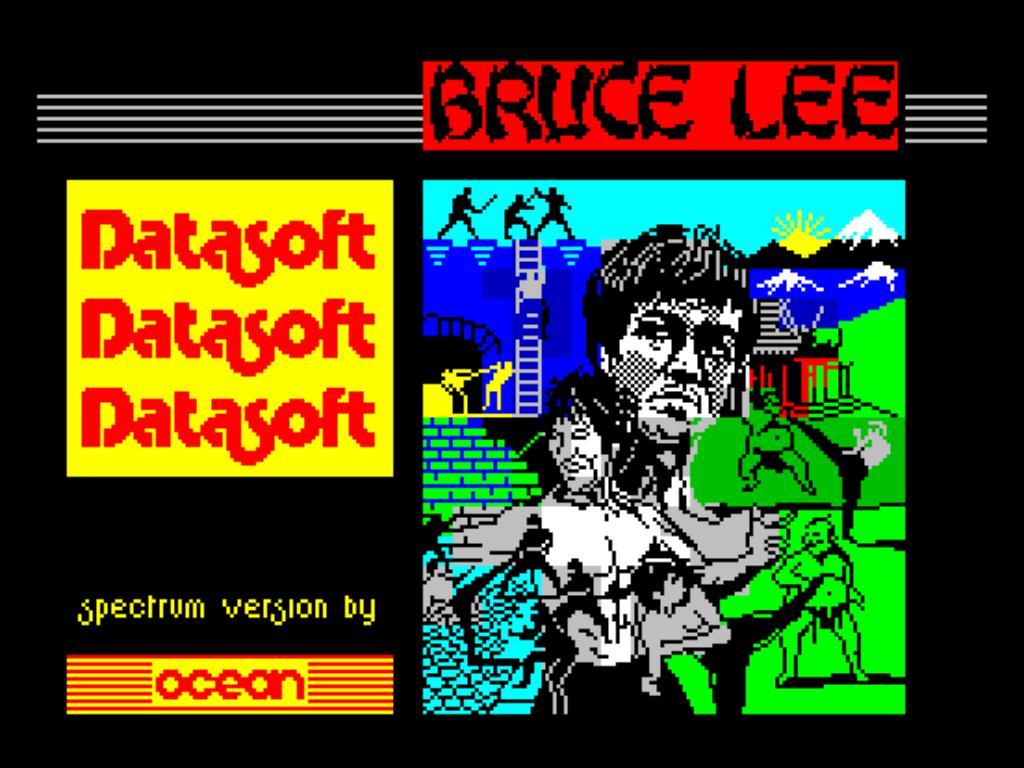Which martial artist is named in the video game?
Keep it short and to the point. Bruce lee. What is the spectrum version by?
Keep it short and to the point. Ocean. 